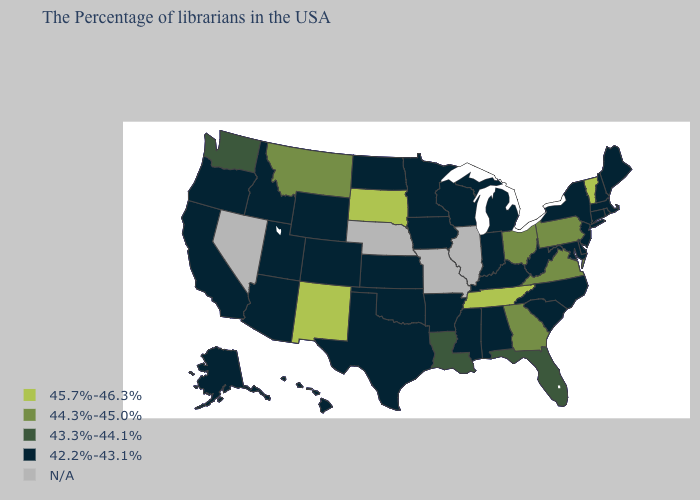What is the value of New Mexico?
Keep it brief. 45.7%-46.3%. What is the highest value in the Northeast ?
Give a very brief answer. 45.7%-46.3%. What is the value of Tennessee?
Short answer required. 45.7%-46.3%. Does the map have missing data?
Write a very short answer. Yes. How many symbols are there in the legend?
Write a very short answer. 5. How many symbols are there in the legend?
Quick response, please. 5. Name the states that have a value in the range 42.2%-43.1%?
Short answer required. Maine, Massachusetts, Rhode Island, New Hampshire, Connecticut, New York, New Jersey, Delaware, Maryland, North Carolina, South Carolina, West Virginia, Michigan, Kentucky, Indiana, Alabama, Wisconsin, Mississippi, Arkansas, Minnesota, Iowa, Kansas, Oklahoma, Texas, North Dakota, Wyoming, Colorado, Utah, Arizona, Idaho, California, Oregon, Alaska, Hawaii. Which states have the lowest value in the South?
Quick response, please. Delaware, Maryland, North Carolina, South Carolina, West Virginia, Kentucky, Alabama, Mississippi, Arkansas, Oklahoma, Texas. What is the value of Texas?
Keep it brief. 42.2%-43.1%. What is the value of Oregon?
Quick response, please. 42.2%-43.1%. What is the value of Virginia?
Concise answer only. 44.3%-45.0%. What is the value of Idaho?
Be succinct. 42.2%-43.1%. Does the first symbol in the legend represent the smallest category?
Short answer required. No. What is the highest value in the USA?
Short answer required. 45.7%-46.3%. 